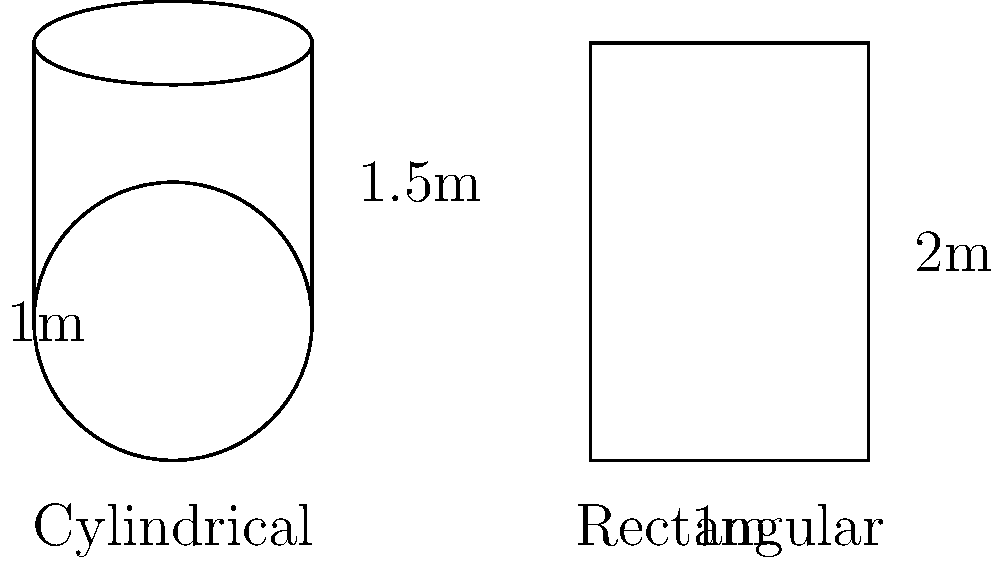As part of your recycling awareness campaign, you're comparing the volume of recyclable materials that can be collected in two different container shapes: a cylindrical container and a rectangular container. The cylindrical container has a radius of 0.5m and a height of 1.5m, while the rectangular container measures 1m x 1m x 2m. Which container can hold more recyclable materials, and by how much (in cubic meters)? To solve this problem, we need to calculate the volume of each container and compare them:

1. Cylindrical container volume:
   $V_{cylinder} = \pi r^2 h$
   $V_{cylinder} = \pi \cdot (0.5m)^2 \cdot 1.5m$
   $V_{cylinder} = \pi \cdot 0.25m^2 \cdot 1.5m$
   $V_{cylinder} \approx 1.178m^3$

2. Rectangular container volume:
   $V_{rectangle} = l \cdot w \cdot h$
   $V_{rectangle} = 1m \cdot 1m \cdot 2m$
   $V_{rectangle} = 2m^3$

3. Difference in volume:
   $\Delta V = V_{rectangle} - V_{cylinder}$
   $\Delta V = 2m^3 - 1.178m^3$
   $\Delta V \approx 0.822m^3$

The rectangular container can hold more recyclable materials, with a difference of approximately 0.822 cubic meters.
Answer: Rectangular, 0.822m³ more 